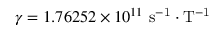Convert formula to latex. <formula><loc_0><loc_0><loc_500><loc_500>\gamma = 1 . 7 6 2 5 2 \times 1 0 ^ { 1 1 } s ^ { - 1 } \cdot T ^ { - 1 }</formula> 